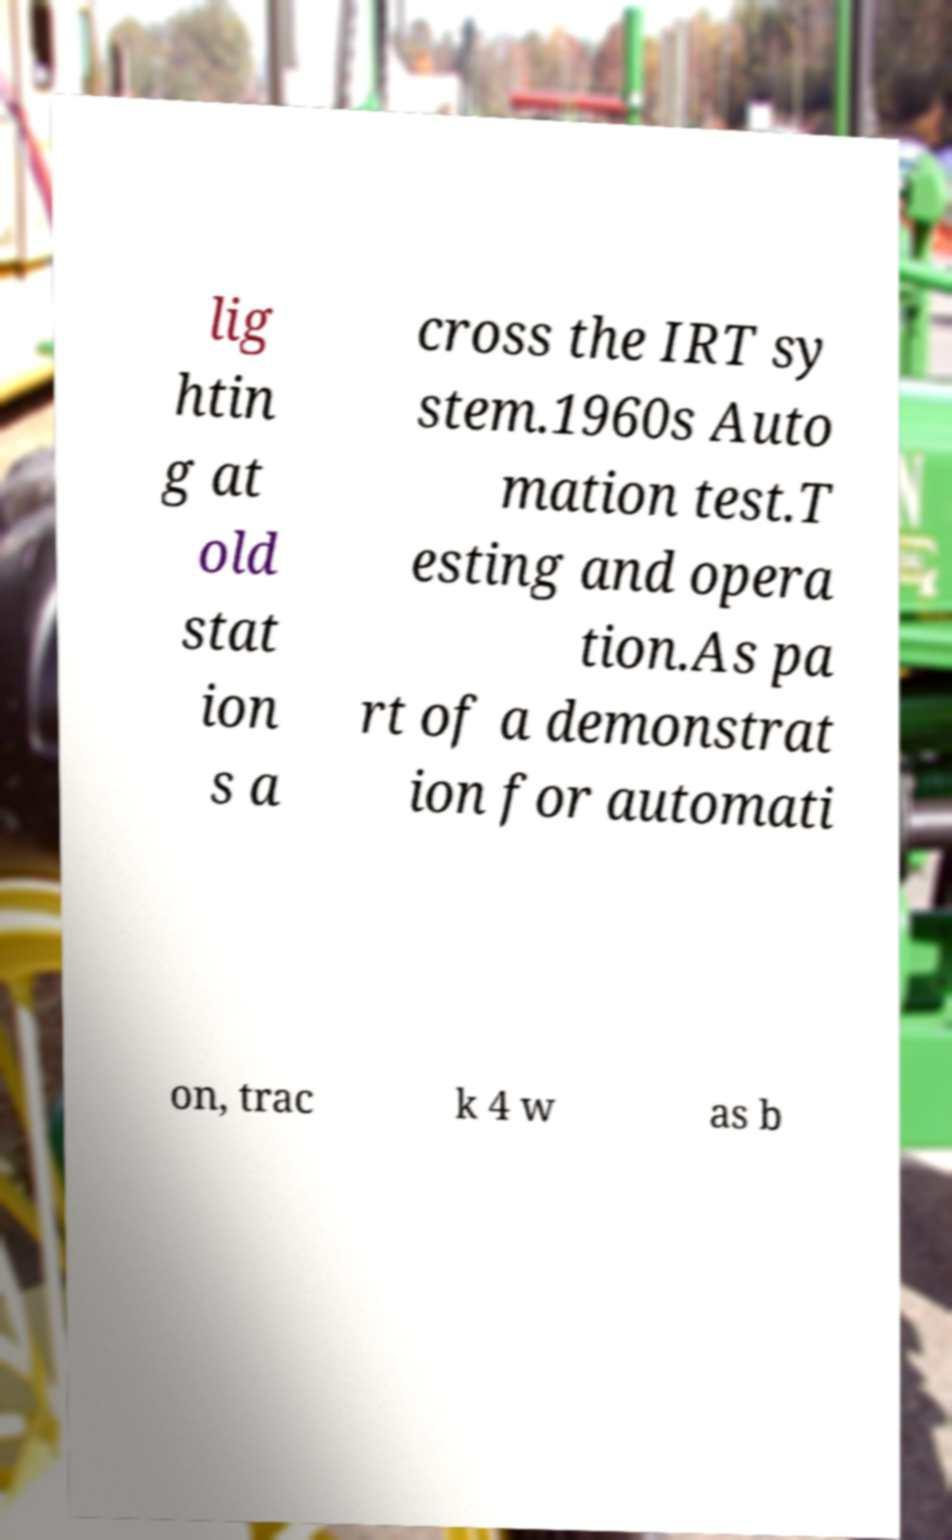Could you assist in decoding the text presented in this image and type it out clearly? lig htin g at old stat ion s a cross the IRT sy stem.1960s Auto mation test.T esting and opera tion.As pa rt of a demonstrat ion for automati on, trac k 4 w as b 